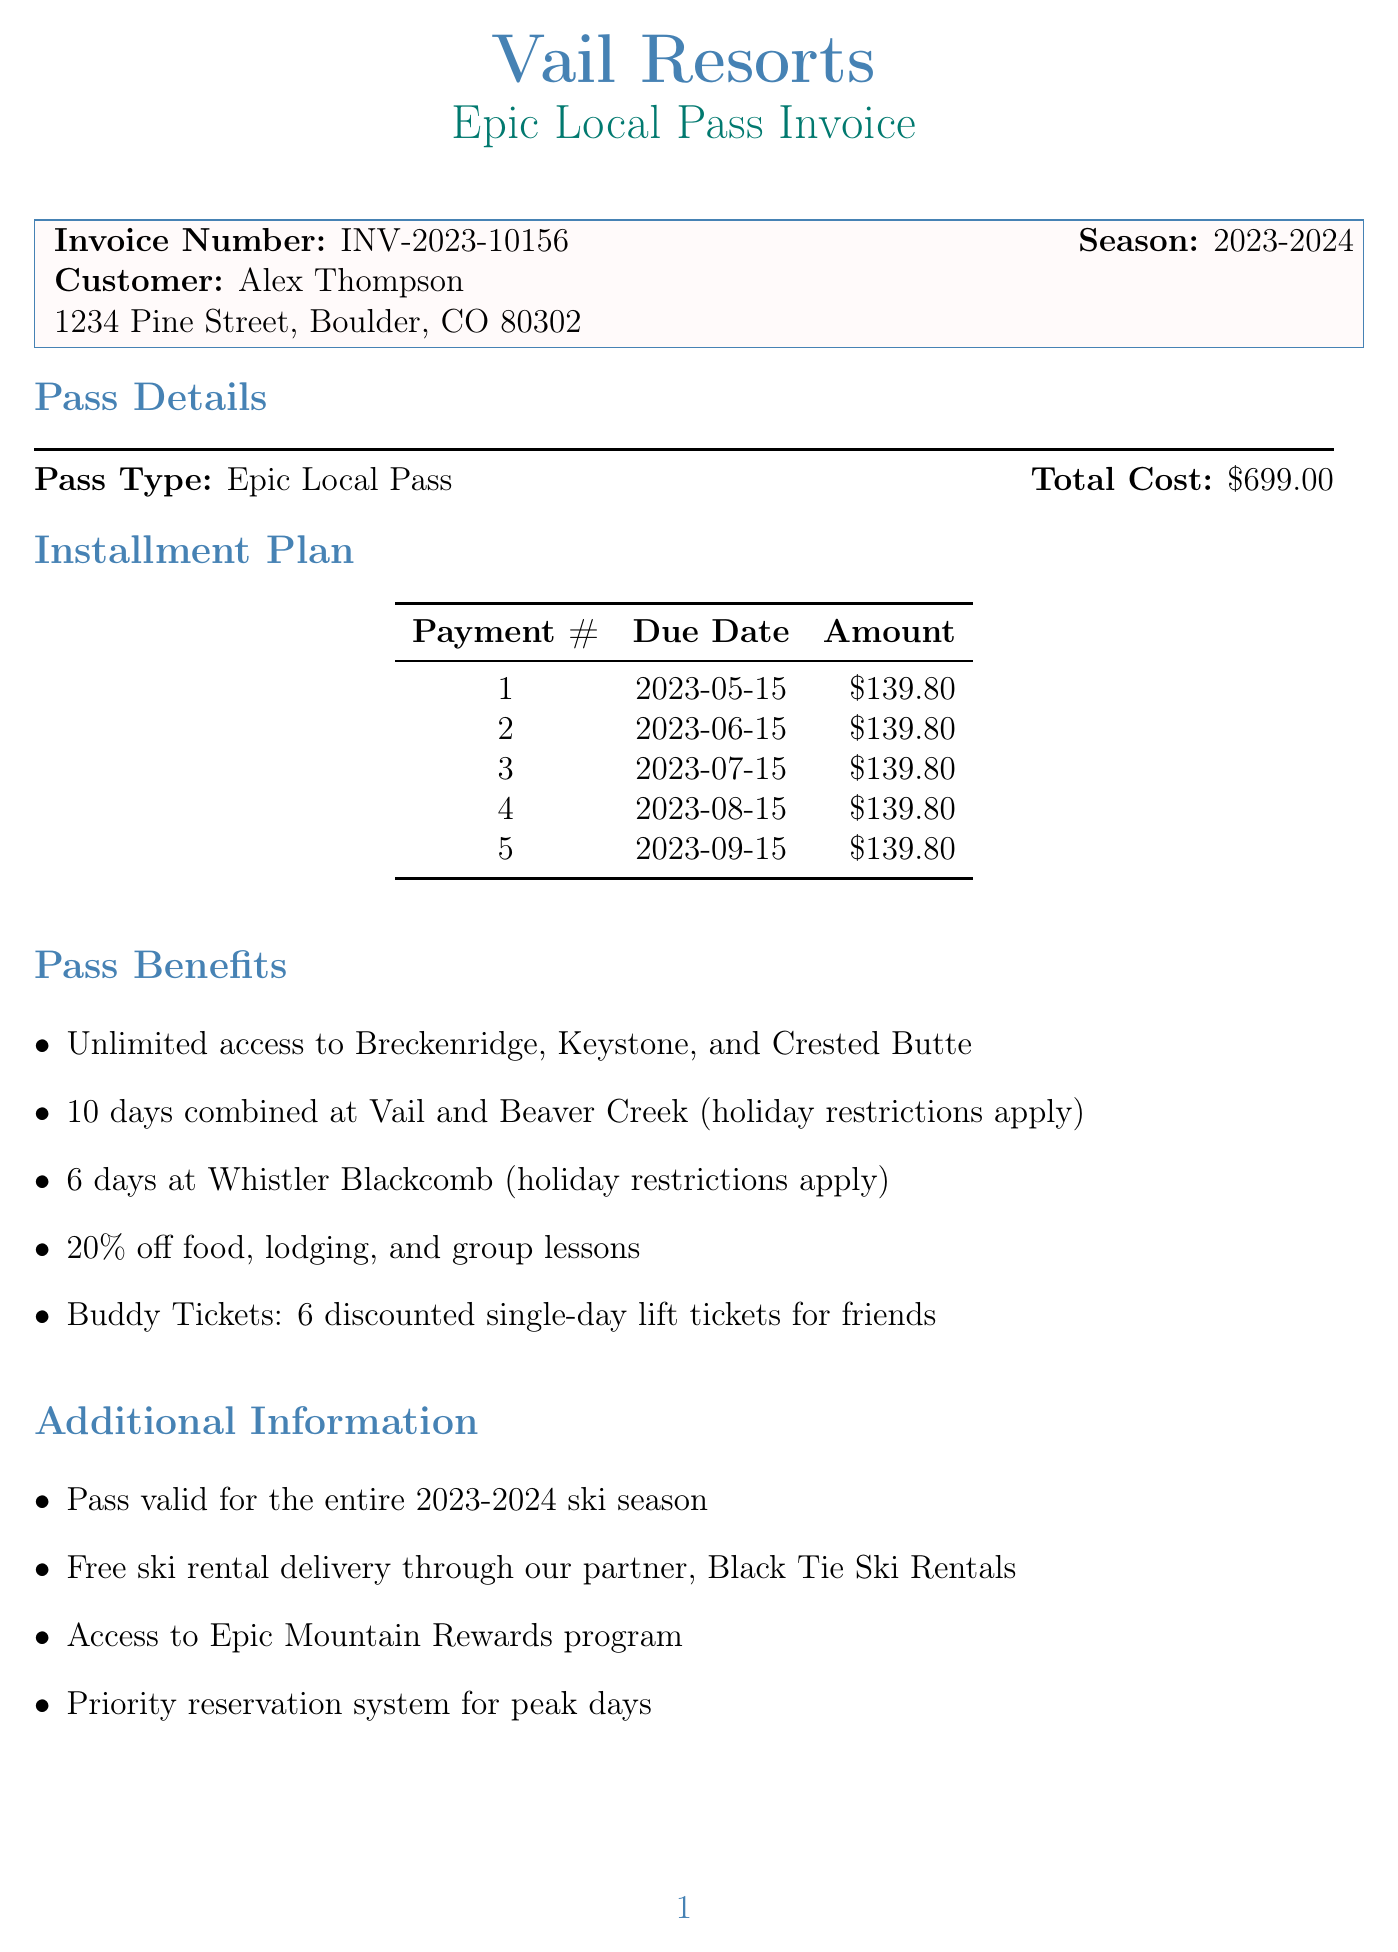what is the invoice number? The invoice number is explicitly stated in the document, identifying it uniquely as INV-2023-10156.
Answer: INV-2023-10156 what is the total cost of the season pass? The total cost is clearly indicated in the document, showing the price for the Epic Local Pass as $699.00.
Answer: $699.00 how many payments are in the installment plan? The document lists five installment payments, detailing each with due dates and amounts.
Answer: 5 what is one benefit of the Epic Local Pass? Among the benefits listed, one is "Unlimited access to Breckenridge, Keystone, and Crested Butte."
Answer: Unlimited access to Breckenridge, Keystone, and Crested Butte when is the second payment due? The due dates for each installment are specified, with the second payment due on June 15, 2023.
Answer: 2023-06-15 what is the email for customer service? Customer service information includes an email address which is provided in the document as epicpass@vailresorts.com.
Answer: epicpass@vailresorts.com what method of payment is not accepted? The document lists accepted payment methods and implies that some, like cash, are not mentioned, indicating they are not accepted.
Answer: Cash (implied) how much is each installment payment? The document details each installment's amount, confirming that each payment is $139.80.
Answer: $139.80 